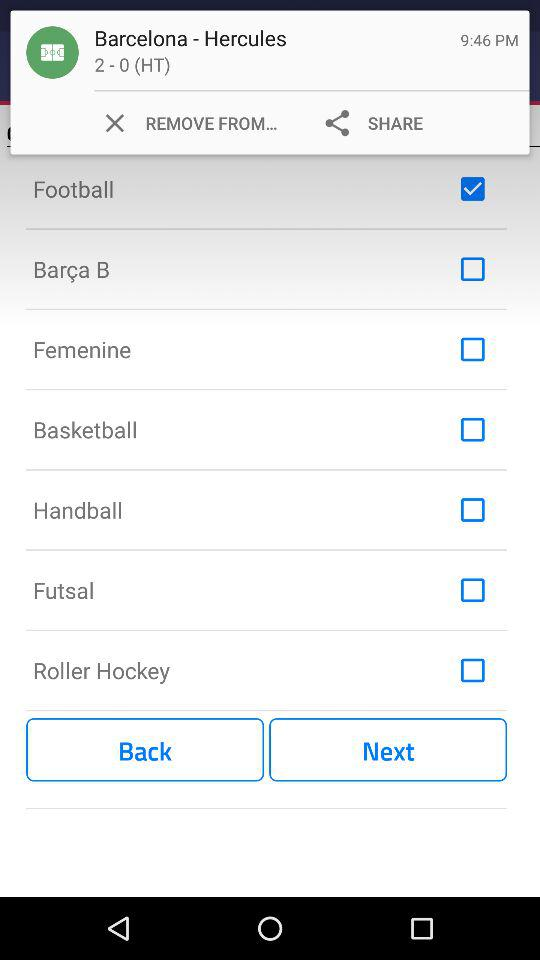What is the status of "Basketball"? The status is "off". 